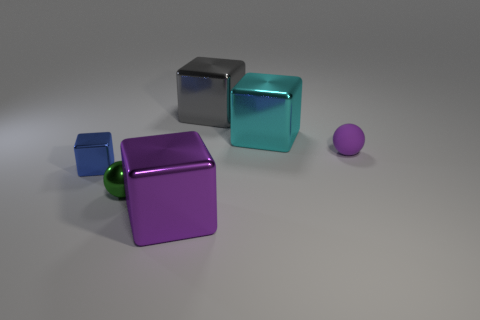Subtract 1 cubes. How many cubes are left? 3 Add 2 cyan cubes. How many objects exist? 8 Subtract all balls. How many objects are left? 4 Subtract 0 cyan balls. How many objects are left? 6 Subtract all small blue rubber objects. Subtract all large metal blocks. How many objects are left? 3 Add 3 tiny blue shiny blocks. How many tiny blue shiny blocks are left? 4 Add 3 small blue things. How many small blue things exist? 4 